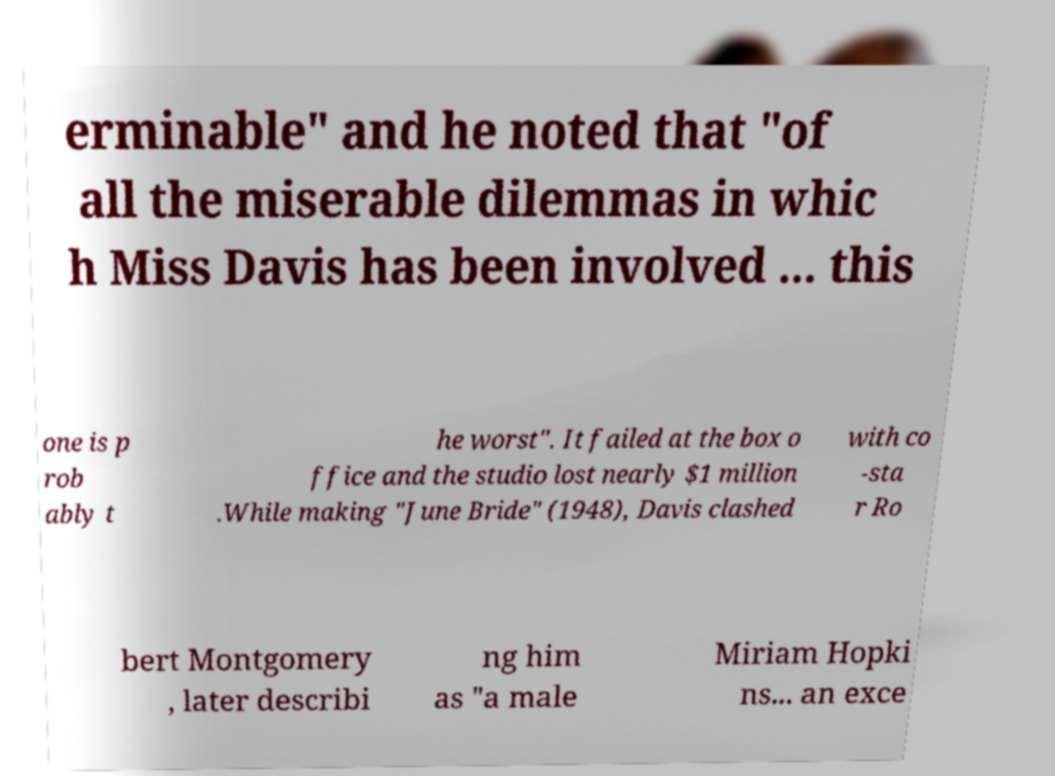For documentation purposes, I need the text within this image transcribed. Could you provide that? erminable" and he noted that "of all the miserable dilemmas in whic h Miss Davis has been involved ... this one is p rob ably t he worst". It failed at the box o ffice and the studio lost nearly $1 million .While making "June Bride" (1948), Davis clashed with co -sta r Ro bert Montgomery , later describi ng him as "a male Miriam Hopki ns... an exce 